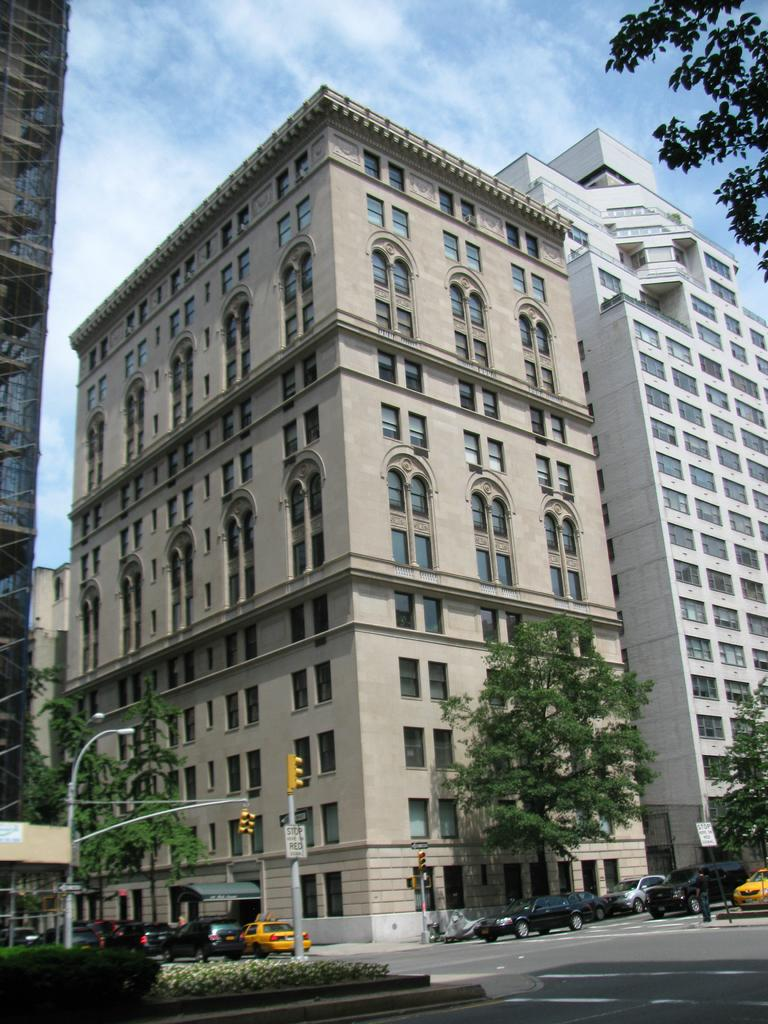What is happening on the road in the image? There are vehicles moving on the road in the image. What type of vegetation can be seen in the image? Shrubs and trees are visible in the image. What structures are present near the road in the image? Traffic signal poles and light poles are visible in the image. What type of buildings can be seen in the image? Tower buildings are present in the image. What is visible in the background of the image? The sky is visible in the background of the image, with clouds present. What type of celery is being served at the party in the image? There is no party or celery present in the image. What type of flowers can be seen in the image? There are no flowers visible in the image; only shrubs, trees, and buildings are present. 